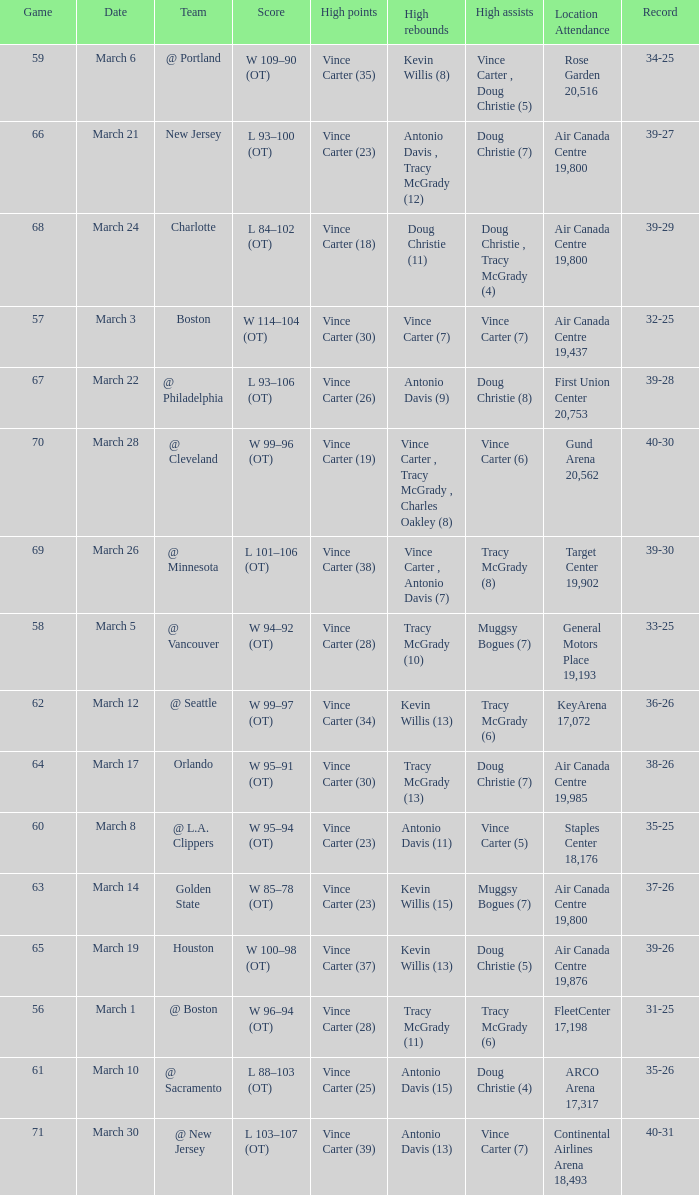Who was the high rebounder against charlotte? Doug Christie (11). 